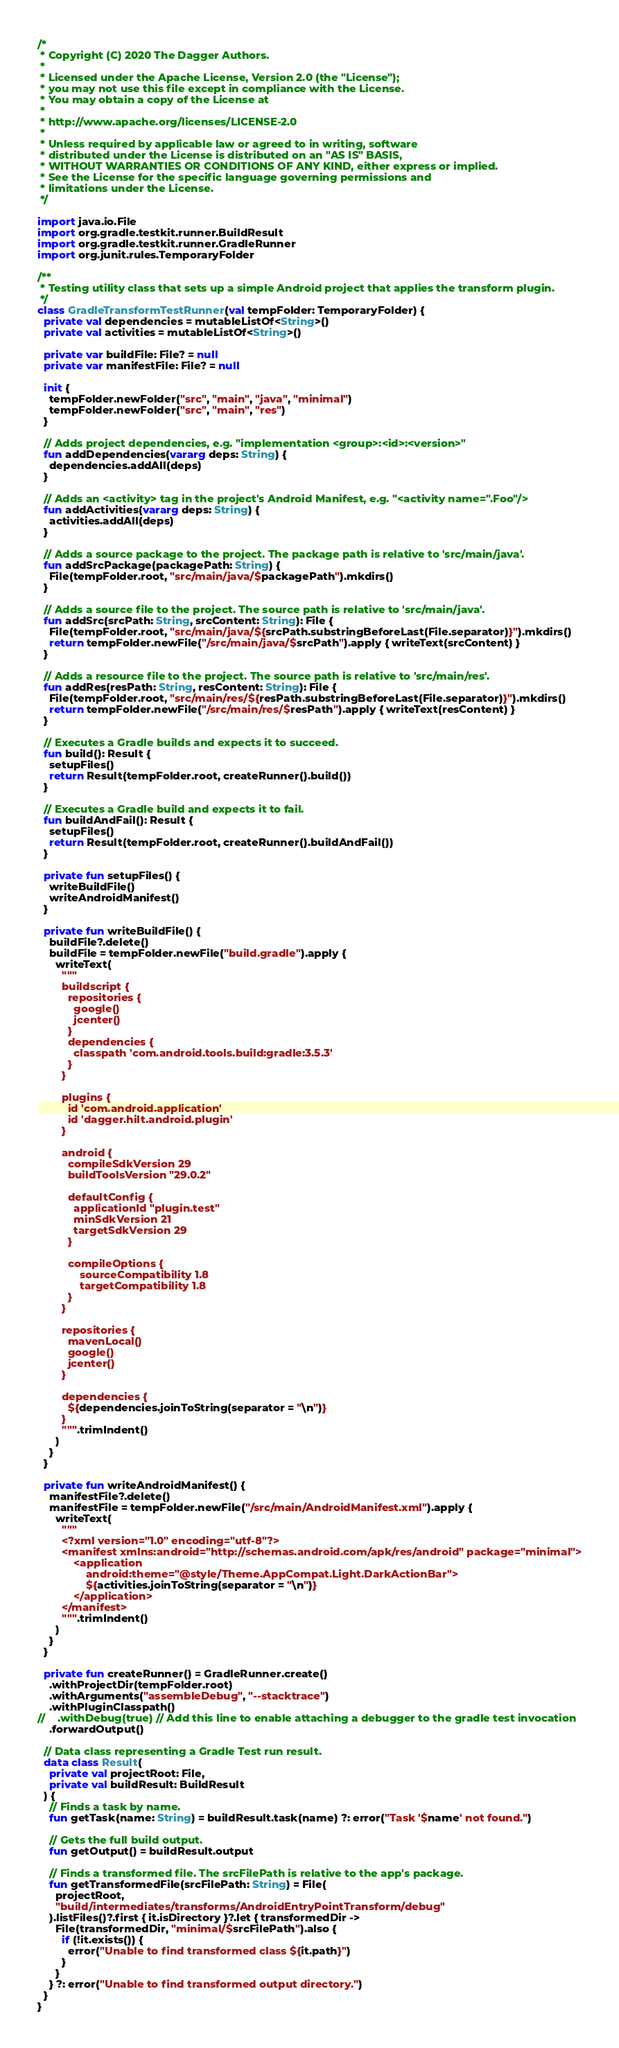Convert code to text. <code><loc_0><loc_0><loc_500><loc_500><_Kotlin_>/*
 * Copyright (C) 2020 The Dagger Authors.
 *
 * Licensed under the Apache License, Version 2.0 (the "License");
 * you may not use this file except in compliance with the License.
 * You may obtain a copy of the License at
 *
 * http://www.apache.org/licenses/LICENSE-2.0
 *
 * Unless required by applicable law or agreed to in writing, software
 * distributed under the License is distributed on an "AS IS" BASIS,
 * WITHOUT WARRANTIES OR CONDITIONS OF ANY KIND, either express or implied.
 * See the License for the specific language governing permissions and
 * limitations under the License.
 */

import java.io.File
import org.gradle.testkit.runner.BuildResult
import org.gradle.testkit.runner.GradleRunner
import org.junit.rules.TemporaryFolder

/**
 * Testing utility class that sets up a simple Android project that applies the transform plugin.
 */
class GradleTransformTestRunner(val tempFolder: TemporaryFolder) {
  private val dependencies = mutableListOf<String>()
  private val activities = mutableListOf<String>()

  private var buildFile: File? = null
  private var manifestFile: File? = null

  init {
    tempFolder.newFolder("src", "main", "java", "minimal")
    tempFolder.newFolder("src", "main", "res")
  }

  // Adds project dependencies, e.g. "implementation <group>:<id>:<version>"
  fun addDependencies(vararg deps: String) {
    dependencies.addAll(deps)
  }

  // Adds an <activity> tag in the project's Android Manifest, e.g. "<activity name=".Foo"/>
  fun addActivities(vararg deps: String) {
    activities.addAll(deps)
  }

  // Adds a source package to the project. The package path is relative to 'src/main/java'.
  fun addSrcPackage(packagePath: String) {
    File(tempFolder.root, "src/main/java/$packagePath").mkdirs()
  }

  // Adds a source file to the project. The source path is relative to 'src/main/java'.
  fun addSrc(srcPath: String, srcContent: String): File {
    File(tempFolder.root, "src/main/java/${srcPath.substringBeforeLast(File.separator)}").mkdirs()
    return tempFolder.newFile("/src/main/java/$srcPath").apply { writeText(srcContent) }
  }

  // Adds a resource file to the project. The source path is relative to 'src/main/res'.
  fun addRes(resPath: String, resContent: String): File {
    File(tempFolder.root, "src/main/res/${resPath.substringBeforeLast(File.separator)}").mkdirs()
    return tempFolder.newFile("/src/main/res/$resPath").apply { writeText(resContent) }
  }

  // Executes a Gradle builds and expects it to succeed.
  fun build(): Result {
    setupFiles()
    return Result(tempFolder.root, createRunner().build())
  }

  // Executes a Gradle build and expects it to fail.
  fun buildAndFail(): Result {
    setupFiles()
    return Result(tempFolder.root, createRunner().buildAndFail())
  }

  private fun setupFiles() {
    writeBuildFile()
    writeAndroidManifest()
  }

  private fun writeBuildFile() {
    buildFile?.delete()
    buildFile = tempFolder.newFile("build.gradle").apply {
      writeText(
        """
        buildscript {
          repositories {
            google()
            jcenter()
          }
          dependencies {
            classpath 'com.android.tools.build:gradle:3.5.3'
          }
        }

        plugins {
          id 'com.android.application'
          id 'dagger.hilt.android.plugin'
        }

        android {
          compileSdkVersion 29
          buildToolsVersion "29.0.2"

          defaultConfig {
            applicationId "plugin.test"
            minSdkVersion 21
            targetSdkVersion 29
          }

          compileOptions {
              sourceCompatibility 1.8
              targetCompatibility 1.8
          }
        }

        repositories {
          mavenLocal()
          google()
          jcenter()
        }

        dependencies {
          ${dependencies.joinToString(separator = "\n")}
        }
        """.trimIndent()
      )
    }
  }

  private fun writeAndroidManifest() {
    manifestFile?.delete()
    manifestFile = tempFolder.newFile("/src/main/AndroidManifest.xml").apply {
      writeText(
        """
        <?xml version="1.0" encoding="utf-8"?>
        <manifest xmlns:android="http://schemas.android.com/apk/res/android" package="minimal">
            <application
                android:theme="@style/Theme.AppCompat.Light.DarkActionBar">
                ${activities.joinToString(separator = "\n")}
            </application>
        </manifest>
        """.trimIndent()
      )
    }
  }

  private fun createRunner() = GradleRunner.create()
    .withProjectDir(tempFolder.root)
    .withArguments("assembleDebug", "--stacktrace")
    .withPluginClasspath()
//    .withDebug(true) // Add this line to enable attaching a debugger to the gradle test invocation
    .forwardOutput()

  // Data class representing a Gradle Test run result.
  data class Result(
    private val projectRoot: File,
    private val buildResult: BuildResult
  ) {
    // Finds a task by name.
    fun getTask(name: String) = buildResult.task(name) ?: error("Task '$name' not found.")

    // Gets the full build output.
    fun getOutput() = buildResult.output

    // Finds a transformed file. The srcFilePath is relative to the app's package.
    fun getTransformedFile(srcFilePath: String) = File(
      projectRoot,
      "build/intermediates/transforms/AndroidEntryPointTransform/debug"
    ).listFiles()?.first { it.isDirectory }?.let { transformedDir ->
      File(transformedDir, "minimal/$srcFilePath").also {
        if (!it.exists()) {
          error("Unable to find transformed class ${it.path}")
        }
      }
    } ?: error("Unable to find transformed output directory.")
  }
}
</code> 